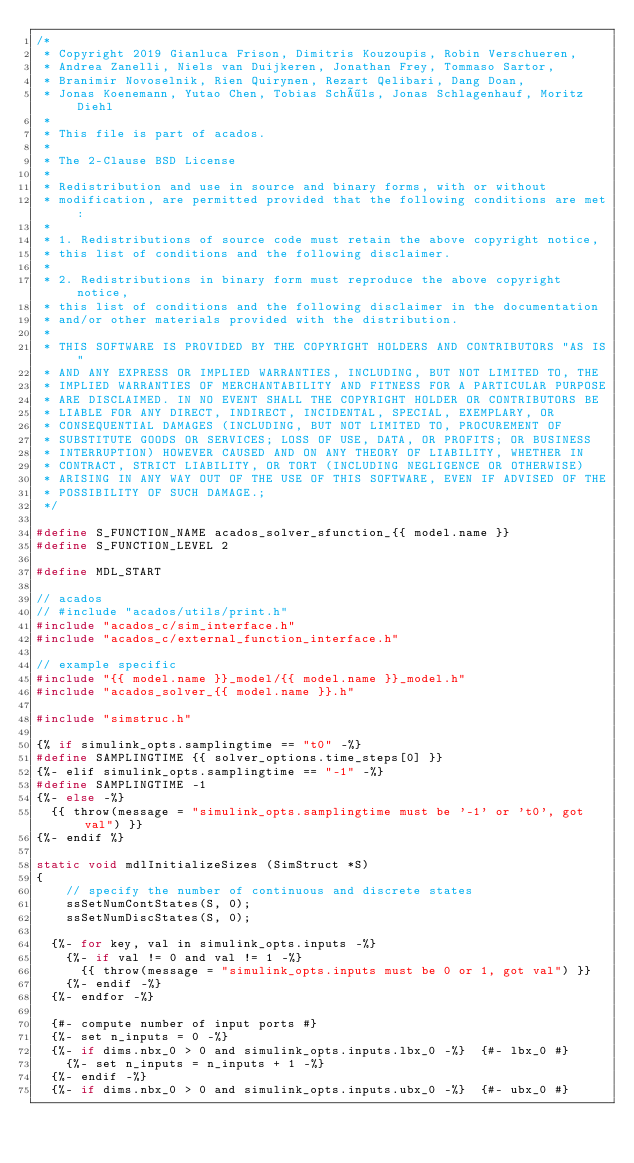Convert code to text. <code><loc_0><loc_0><loc_500><loc_500><_C_>/*
 * Copyright 2019 Gianluca Frison, Dimitris Kouzoupis, Robin Verschueren,
 * Andrea Zanelli, Niels van Duijkeren, Jonathan Frey, Tommaso Sartor,
 * Branimir Novoselnik, Rien Quirynen, Rezart Qelibari, Dang Doan,
 * Jonas Koenemann, Yutao Chen, Tobias Schöls, Jonas Schlagenhauf, Moritz Diehl
 *
 * This file is part of acados.
 *
 * The 2-Clause BSD License
 *
 * Redistribution and use in source and binary forms, with or without
 * modification, are permitted provided that the following conditions are met:
 *
 * 1. Redistributions of source code must retain the above copyright notice,
 * this list of conditions and the following disclaimer.
 *
 * 2. Redistributions in binary form must reproduce the above copyright notice,
 * this list of conditions and the following disclaimer in the documentation
 * and/or other materials provided with the distribution.
 *
 * THIS SOFTWARE IS PROVIDED BY THE COPYRIGHT HOLDERS AND CONTRIBUTORS "AS IS"
 * AND ANY EXPRESS OR IMPLIED WARRANTIES, INCLUDING, BUT NOT LIMITED TO, THE
 * IMPLIED WARRANTIES OF MERCHANTABILITY AND FITNESS FOR A PARTICULAR PURPOSE
 * ARE DISCLAIMED. IN NO EVENT SHALL THE COPYRIGHT HOLDER OR CONTRIBUTORS BE
 * LIABLE FOR ANY DIRECT, INDIRECT, INCIDENTAL, SPECIAL, EXEMPLARY, OR
 * CONSEQUENTIAL DAMAGES (INCLUDING, BUT NOT LIMITED TO, PROCUREMENT OF
 * SUBSTITUTE GOODS OR SERVICES; LOSS OF USE, DATA, OR PROFITS; OR BUSINESS
 * INTERRUPTION) HOWEVER CAUSED AND ON ANY THEORY OF LIABILITY, WHETHER IN
 * CONTRACT, STRICT LIABILITY, OR TORT (INCLUDING NEGLIGENCE OR OTHERWISE)
 * ARISING IN ANY WAY OUT OF THE USE OF THIS SOFTWARE, EVEN IF ADVISED OF THE
 * POSSIBILITY OF SUCH DAMAGE.;
 */

#define S_FUNCTION_NAME acados_solver_sfunction_{{ model.name }}
#define S_FUNCTION_LEVEL 2

#define MDL_START

// acados
// #include "acados/utils/print.h"
#include "acados_c/sim_interface.h"
#include "acados_c/external_function_interface.h"

// example specific
#include "{{ model.name }}_model/{{ model.name }}_model.h"
#include "acados_solver_{{ model.name }}.h"

#include "simstruc.h"

{% if simulink_opts.samplingtime == "t0" -%}
#define SAMPLINGTIME {{ solver_options.time_steps[0] }}
{%- elif simulink_opts.samplingtime == "-1" -%}
#define SAMPLINGTIME -1
{%- else -%}
  {{ throw(message = "simulink_opts.samplingtime must be '-1' or 't0', got val") }}
{%- endif %}

static void mdlInitializeSizes (SimStruct *S)
{
    // specify the number of continuous and discrete states
    ssSetNumContStates(S, 0);
    ssSetNumDiscStates(S, 0);

  {%- for key, val in simulink_opts.inputs -%}
    {%- if val != 0 and val != 1 -%}
      {{ throw(message = "simulink_opts.inputs must be 0 or 1, got val") }}
    {%- endif -%}
  {%- endfor -%}

  {#- compute number of input ports #}
  {%- set n_inputs = 0 -%}
  {%- if dims.nbx_0 > 0 and simulink_opts.inputs.lbx_0 -%}  {#- lbx_0 #}
    {%- set n_inputs = n_inputs + 1 -%}
  {%- endif -%}
  {%- if dims.nbx_0 > 0 and simulink_opts.inputs.ubx_0 -%}  {#- ubx_0 #}</code> 